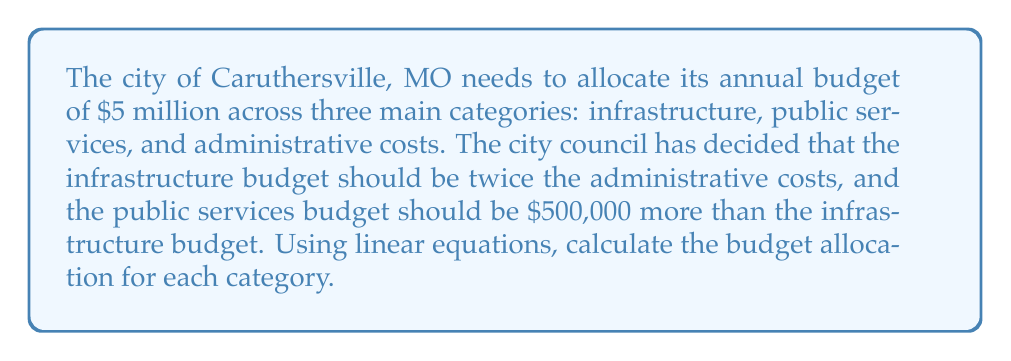Give your solution to this math problem. Let's define our variables:
$x$ = administrative costs
$y$ = infrastructure budget
$z$ = public services budget

Step 1: Express the total budget as an equation
$$x + y + z = 5,000,000$$

Step 2: Express the relationship between infrastructure and administrative costs
$$y = 2x$$

Step 3: Express the relationship between public services and infrastructure
$$z = y + 500,000$$

Step 4: Substitute the expressions for y and z into the total budget equation
$$x + 2x + (2x + 500,000) = 5,000,000$$

Step 5: Simplify the equation
$$5x + 500,000 = 5,000,000$$

Step 6: Solve for x (administrative costs)
$$5x = 4,500,000$$
$$x = 900,000$$

Step 7: Calculate y (infrastructure budget)
$$y = 2x = 2(900,000) = 1,800,000$$

Step 8: Calculate z (public services budget)
$$z = y + 500,000 = 1,800,000 + 500,000 = 2,300,000$$

Therefore, the budget allocations are:
Administrative costs: $900,000
Infrastructure: $1,800,000
Public services: $2,300,000
Answer: Administrative: $900,000; Infrastructure: $1,800,000; Public services: $2,300,000 